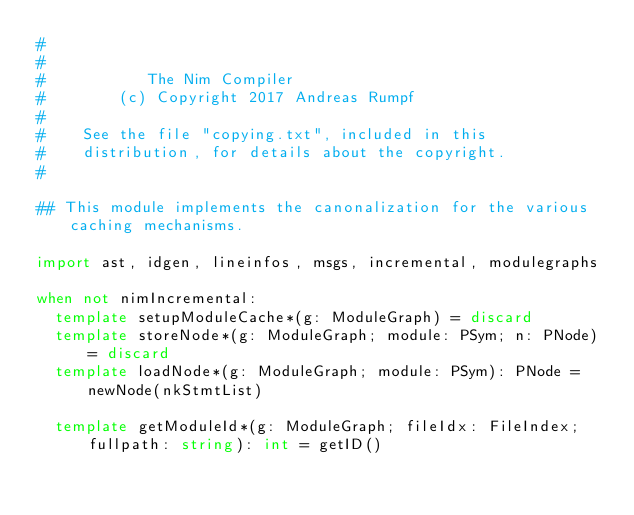<code> <loc_0><loc_0><loc_500><loc_500><_Nim_>#
#
#           The Nim Compiler
#        (c) Copyright 2017 Andreas Rumpf
#
#    See the file "copying.txt", included in this
#    distribution, for details about the copyright.
#

## This module implements the canonalization for the various caching mechanisms.

import ast, idgen, lineinfos, msgs, incremental, modulegraphs

when not nimIncremental:
  template setupModuleCache*(g: ModuleGraph) = discard
  template storeNode*(g: ModuleGraph; module: PSym; n: PNode) = discard
  template loadNode*(g: ModuleGraph; module: PSym): PNode = newNode(nkStmtList)

  template getModuleId*(g: ModuleGraph; fileIdx: FileIndex; fullpath: string): int = getID()
</code> 